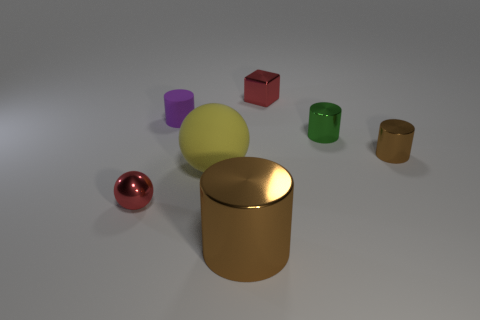How many small purple things have the same material as the large yellow sphere?
Your answer should be very brief. 1. How big is the brown object right of the metallic cylinder in front of the small object that is in front of the yellow sphere?
Provide a succinct answer. Small. There is a cube; what number of brown metallic cylinders are behind it?
Make the answer very short. 0. Is the number of tiny red shiny balls greater than the number of small gray matte balls?
Keep it short and to the point. Yes. What size is the metal block that is the same color as the tiny metallic ball?
Your answer should be compact. Small. There is a thing that is left of the metal block and behind the big sphere; what is its size?
Your response must be concise. Small. What is the material of the red thing behind the small cylinder that is left of the brown metallic cylinder that is to the left of the red block?
Provide a succinct answer. Metal. What is the material of the other cylinder that is the same color as the big metallic cylinder?
Keep it short and to the point. Metal. Do the tiny cylinder to the left of the green metal cylinder and the small object that is behind the purple thing have the same color?
Offer a terse response. No. What shape is the brown shiny object in front of the brown shiny object behind the large object to the right of the matte sphere?
Your answer should be compact. Cylinder. 